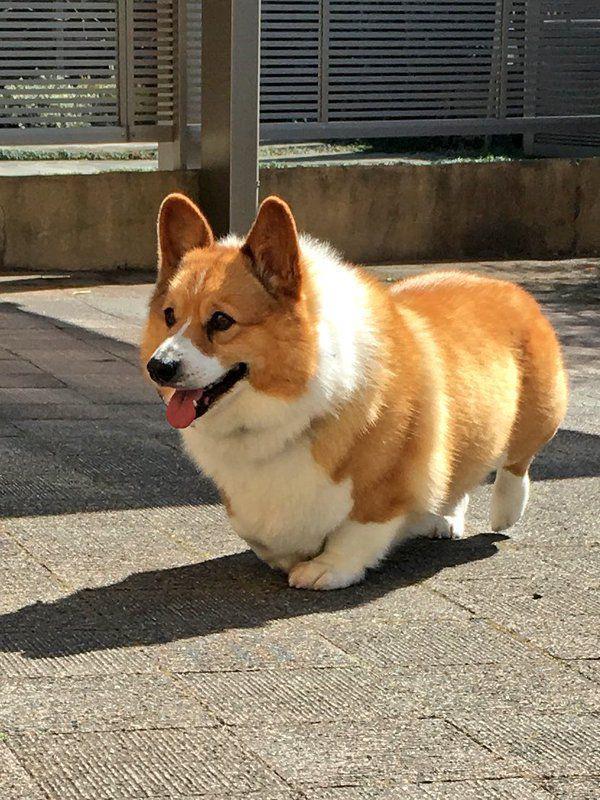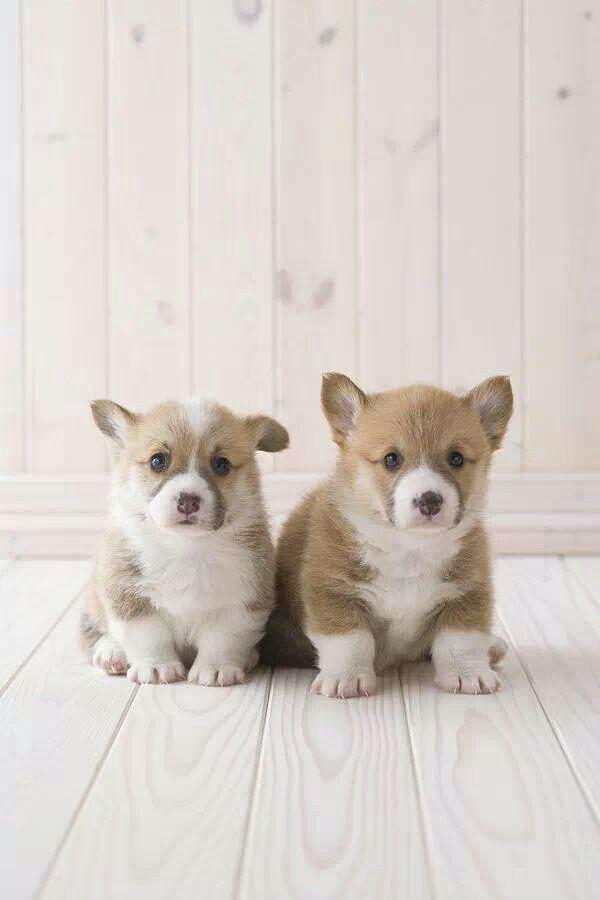The first image is the image on the left, the second image is the image on the right. Assess this claim about the two images: "A dog in the image on the left is lying down with its tongue hanging out.". Correct or not? Answer yes or no. No. The first image is the image on the left, the second image is the image on the right. For the images displayed, is the sentence "The corgi's are outside laying in or near the green grass" factually correct? Answer yes or no. No. 